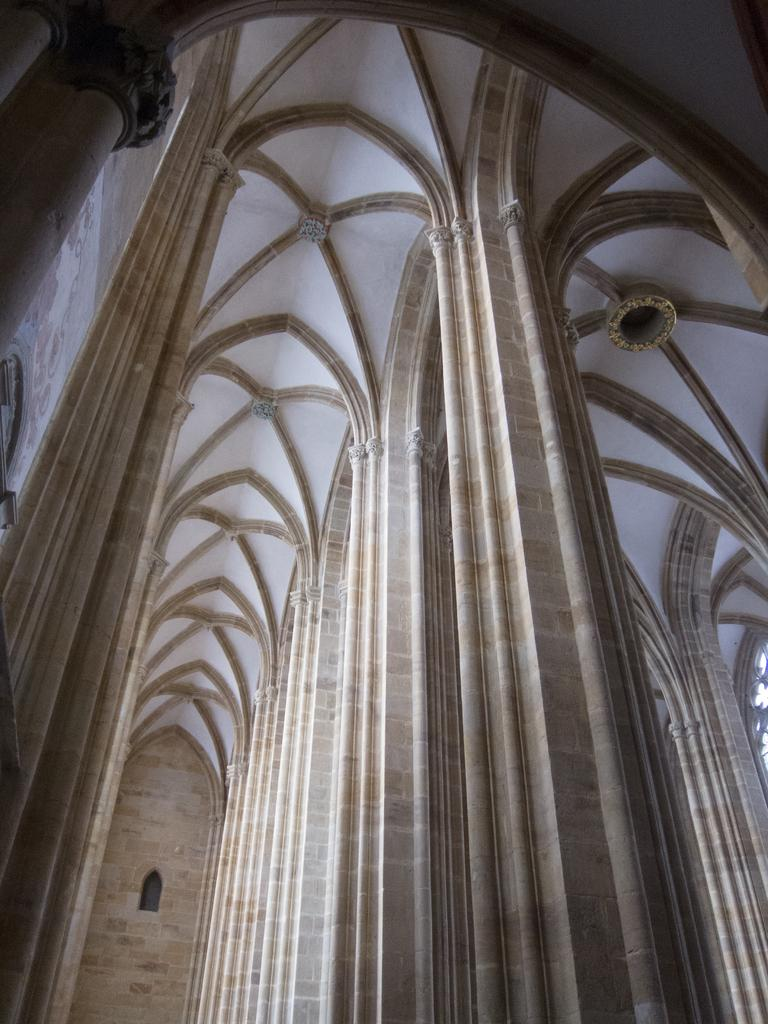What architectural feature can be seen in the image? There is a window in the image. What other structural elements are present in the image? There are pillars in the image. What part of the building can be seen in the image? The ceiling is visible in the image. What type of location is depicted in the image? The image is an inside view of a building. What type of bird can be heard singing in the image? There is no bird present in the image, and therefore no singing can be heard. How many people are laughing in the image? There are no people present in the image, and therefore no one is laughing. 